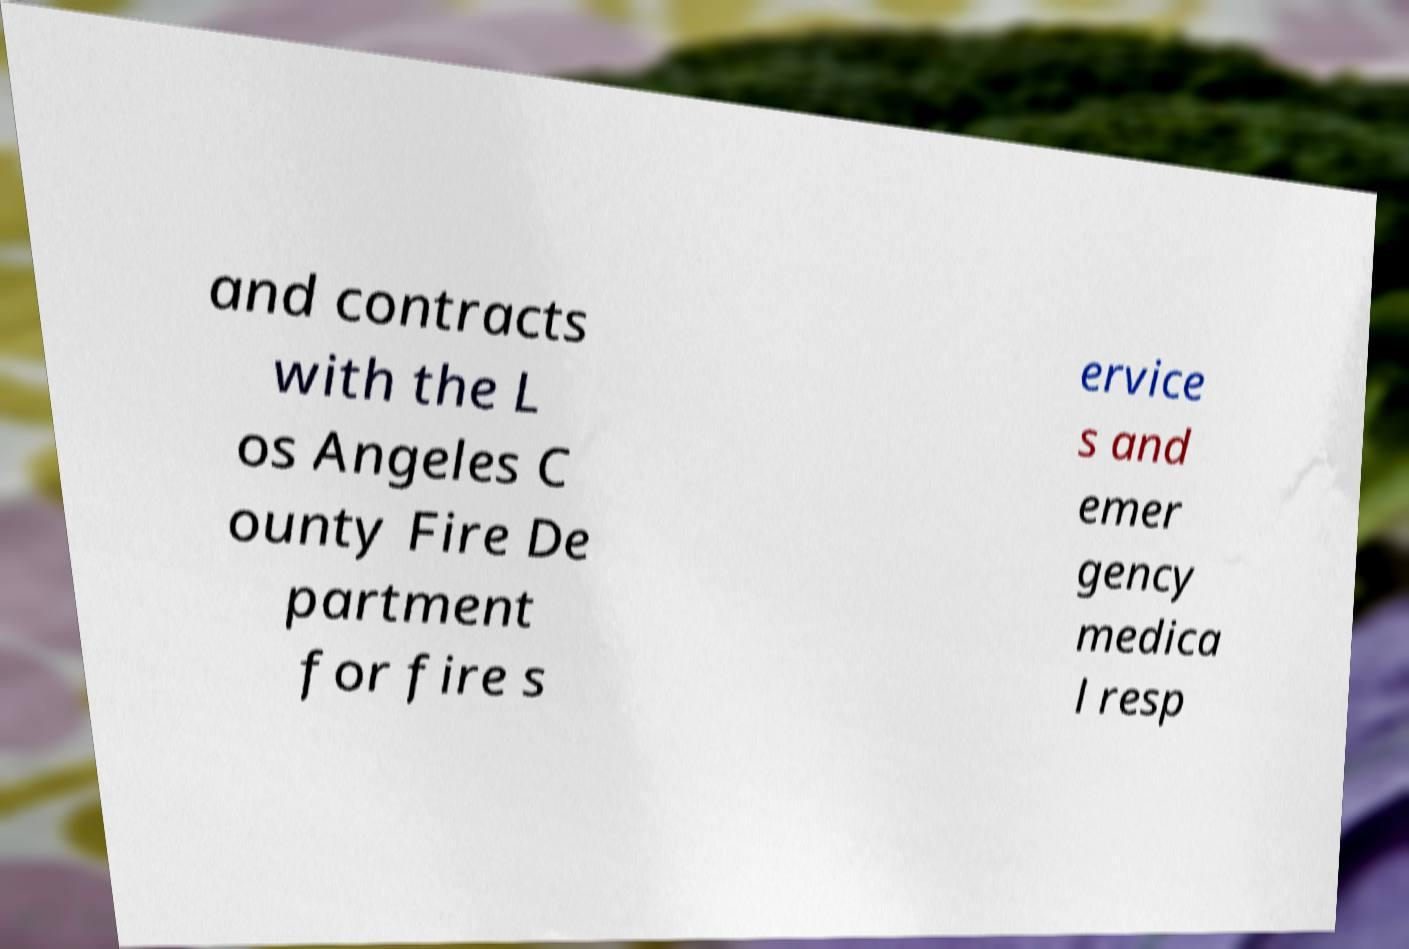Please read and relay the text visible in this image. What does it say? and contracts with the L os Angeles C ounty Fire De partment for fire s ervice s and emer gency medica l resp 